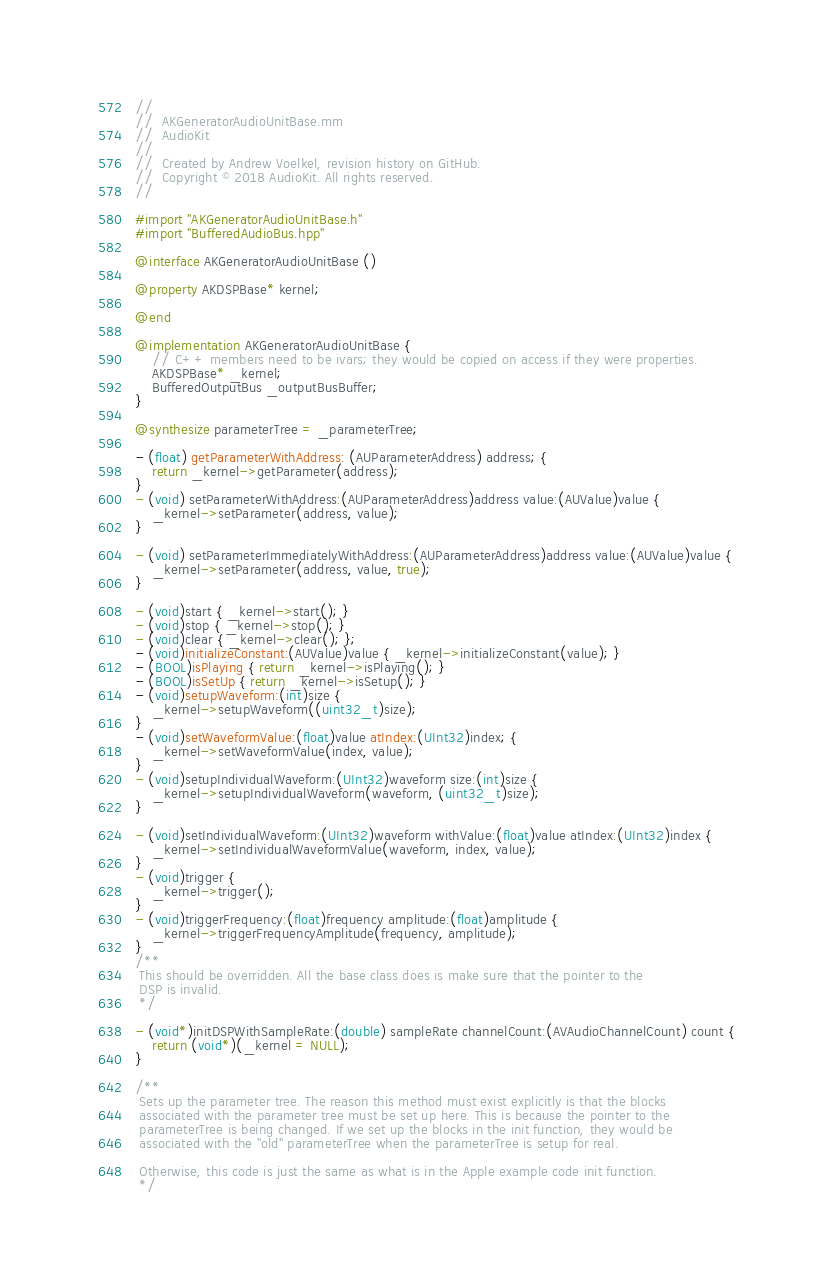Convert code to text. <code><loc_0><loc_0><loc_500><loc_500><_ObjectiveC_>//
//  AKGeneratorAudioUnitBase.mm
//  AudioKit
//
//  Created by Andrew Voelkel, revision history on GitHub.
//  Copyright © 2018 AudioKit. All rights reserved.
//

#import "AKGeneratorAudioUnitBase.h"
#import "BufferedAudioBus.hpp"

@interface AKGeneratorAudioUnitBase ()

@property AKDSPBase* kernel;

@end

@implementation AKGeneratorAudioUnitBase {
    // C++ members need to be ivars; they would be copied on access if they were properties.
    AKDSPBase* _kernel;
    BufferedOutputBus _outputBusBuffer;
}

@synthesize parameterTree = _parameterTree;

- (float) getParameterWithAddress: (AUParameterAddress) address; {
    return _kernel->getParameter(address);
}
- (void) setParameterWithAddress:(AUParameterAddress)address value:(AUValue)value {
    _kernel->setParameter(address, value);
}

- (void) setParameterImmediatelyWithAddress:(AUParameterAddress)address value:(AUValue)value {
    _kernel->setParameter(address, value, true);
}

- (void)start { _kernel->start(); }
- (void)stop { _kernel->stop(); }
- (void)clear { _kernel->clear(); };
- (void)initializeConstant:(AUValue)value { _kernel->initializeConstant(value); }
- (BOOL)isPlaying { return _kernel->isPlaying(); }
- (BOOL)isSetUp { return _kernel->isSetup(); }
- (void)setupWaveform:(int)size {
    _kernel->setupWaveform((uint32_t)size);
}
- (void)setWaveformValue:(float)value atIndex:(UInt32)index; {
    _kernel->setWaveformValue(index, value);
}
- (void)setupIndividualWaveform:(UInt32)waveform size:(int)size {
    _kernel->setupIndividualWaveform(waveform, (uint32_t)size);
}

- (void)setIndividualWaveform:(UInt32)waveform withValue:(float)value atIndex:(UInt32)index {
    _kernel->setIndividualWaveformValue(waveform, index, value);
}
- (void)trigger {
    _kernel->trigger();
}
- (void)triggerFrequency:(float)frequency amplitude:(float)amplitude {
    _kernel->triggerFrequencyAmplitude(frequency, amplitude);
}
/**
 This should be overridden. All the base class does is make sure that the pointer to the
 DSP is invalid.
 */

- (void*)initDSPWithSampleRate:(double) sampleRate channelCount:(AVAudioChannelCount) count {
    return (void*)(_kernel = NULL);
}

/**
 Sets up the parameter tree. The reason this method must exist explicitly is that the blocks
 associated with the parameter tree must be set up here. This is because the pointer to the
 parameterTree is being changed. If we set up the blocks in the init function, they would be
 associated with the "old" parameterTree when the parameterTree is setup for real.

 Otherwise, this code is just the same as what is in the Apple example code init function.
 */
</code> 